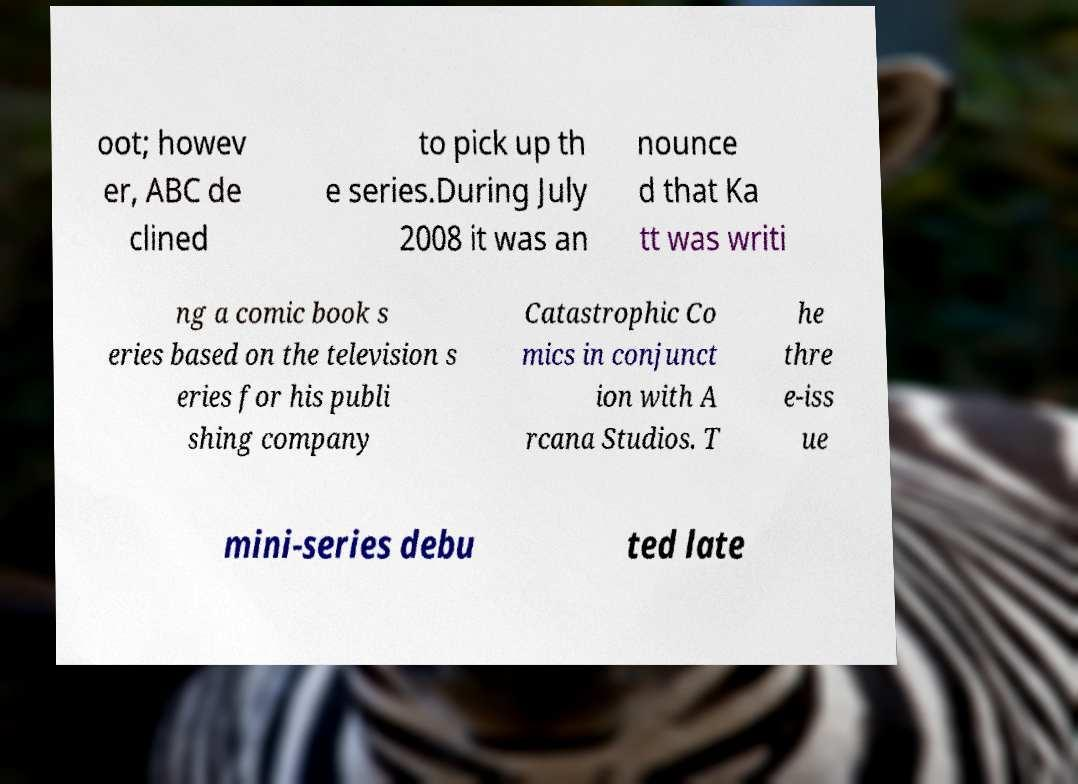I need the written content from this picture converted into text. Can you do that? oot; howev er, ABC de clined to pick up th e series.During July 2008 it was an nounce d that Ka tt was writi ng a comic book s eries based on the television s eries for his publi shing company Catastrophic Co mics in conjunct ion with A rcana Studios. T he thre e-iss ue mini-series debu ted late 